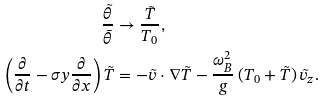<formula> <loc_0><loc_0><loc_500><loc_500>\frac { \tilde { \theta } } { \bar { \theta } } & \rightarrow \frac { \tilde { T } } { T _ { 0 } } , \\ \left ( \frac { \partial } { \partial t } - \sigma y \frac { \partial } { \partial x } \right ) \tilde { T } & = - \tilde { v } \cdot \nabla \tilde { T } - \frac { \omega _ { B } ^ { 2 } } { g } \left ( T _ { 0 } + \tilde { T } \right ) \tilde { v } _ { z } .</formula> 